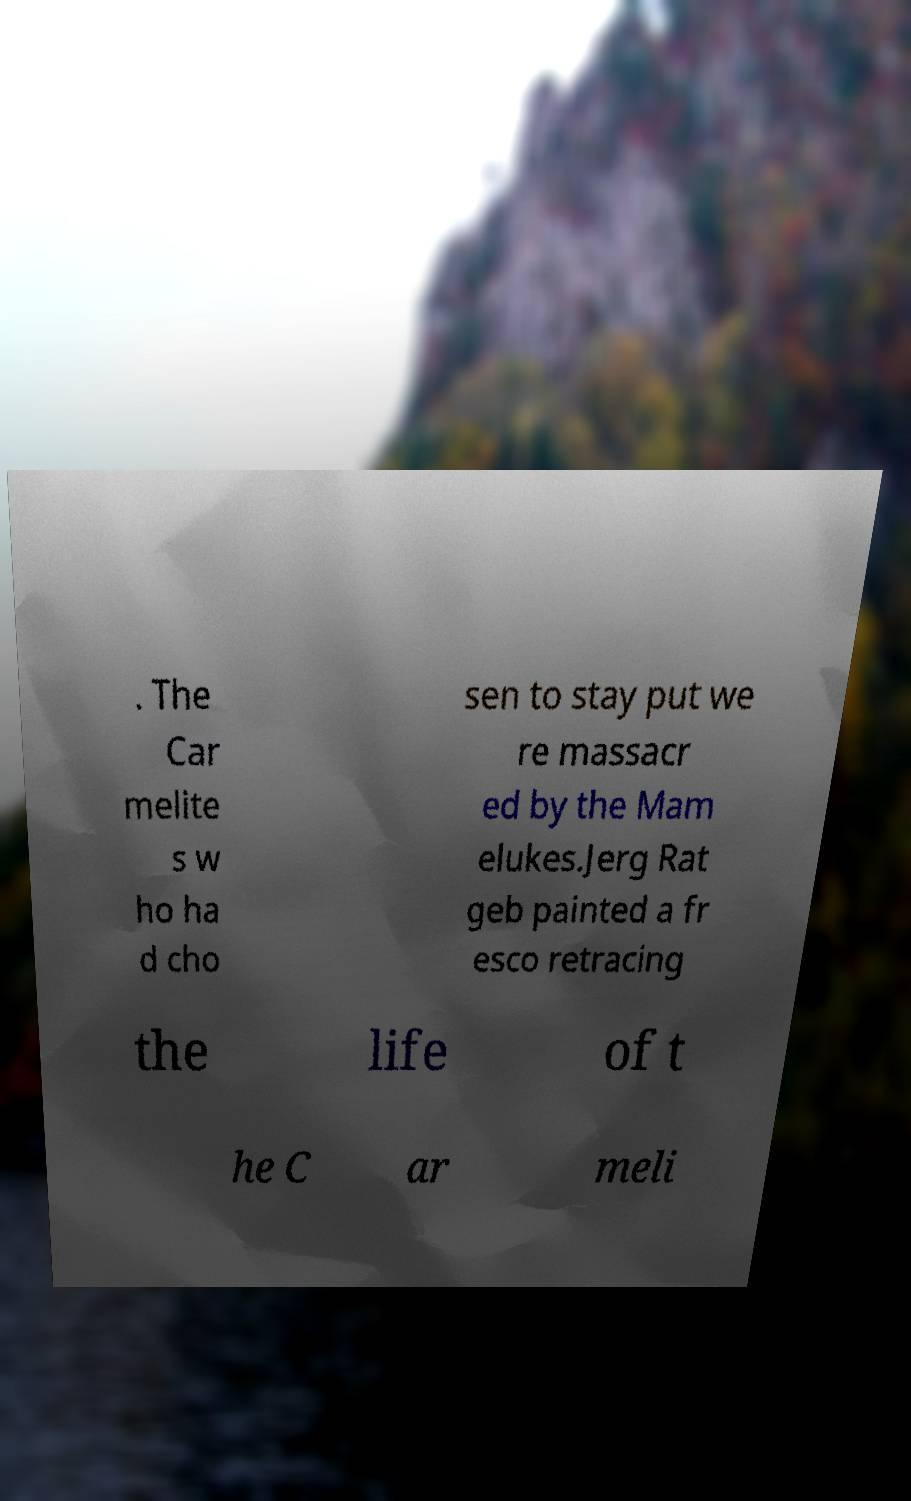What messages or text are displayed in this image? I need them in a readable, typed format. . The Car melite s w ho ha d cho sen to stay put we re massacr ed by the Mam elukes.Jerg Rat geb painted a fr esco retracing the life of t he C ar meli 